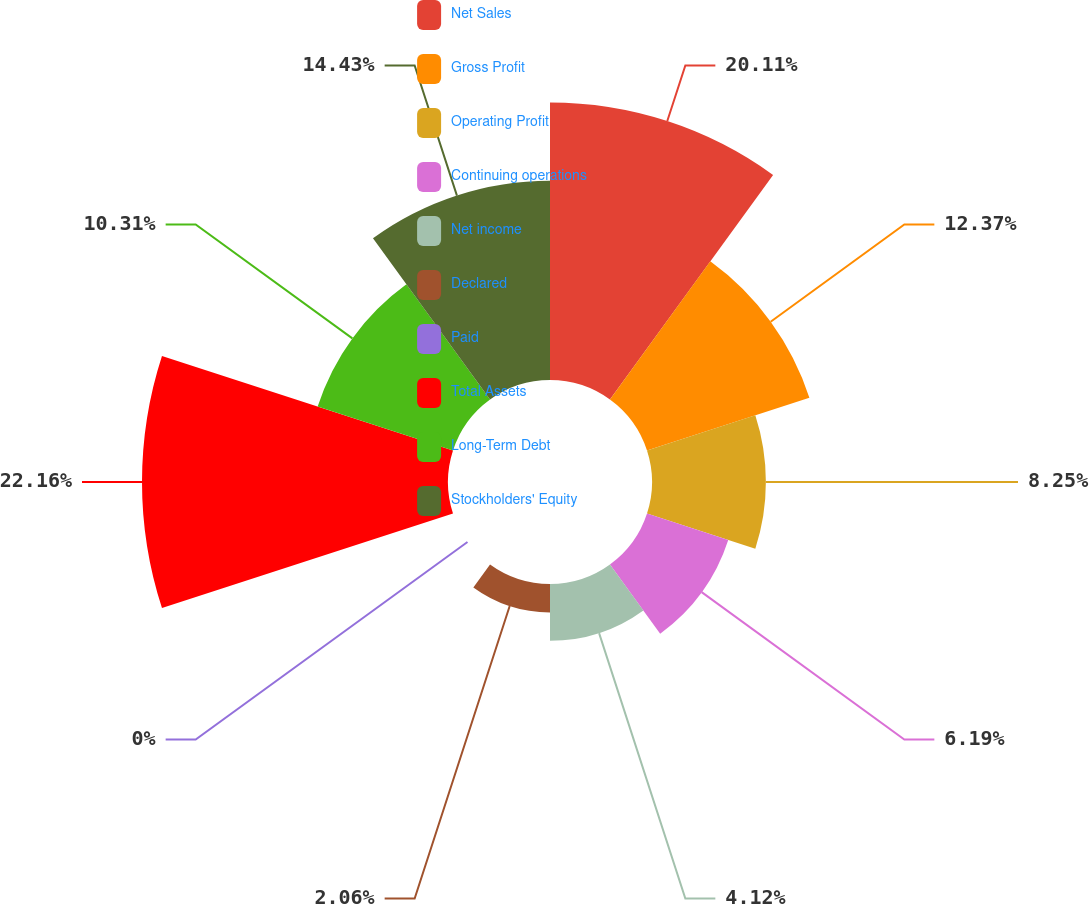Convert chart. <chart><loc_0><loc_0><loc_500><loc_500><pie_chart><fcel>Net Sales<fcel>Gross Profit<fcel>Operating Profit<fcel>Continuing operations<fcel>Net income<fcel>Declared<fcel>Paid<fcel>Total Assets<fcel>Long-Term Debt<fcel>Stockholders' Equity<nl><fcel>20.11%<fcel>12.37%<fcel>8.25%<fcel>6.19%<fcel>4.12%<fcel>2.06%<fcel>0.0%<fcel>22.17%<fcel>10.31%<fcel>14.43%<nl></chart> 